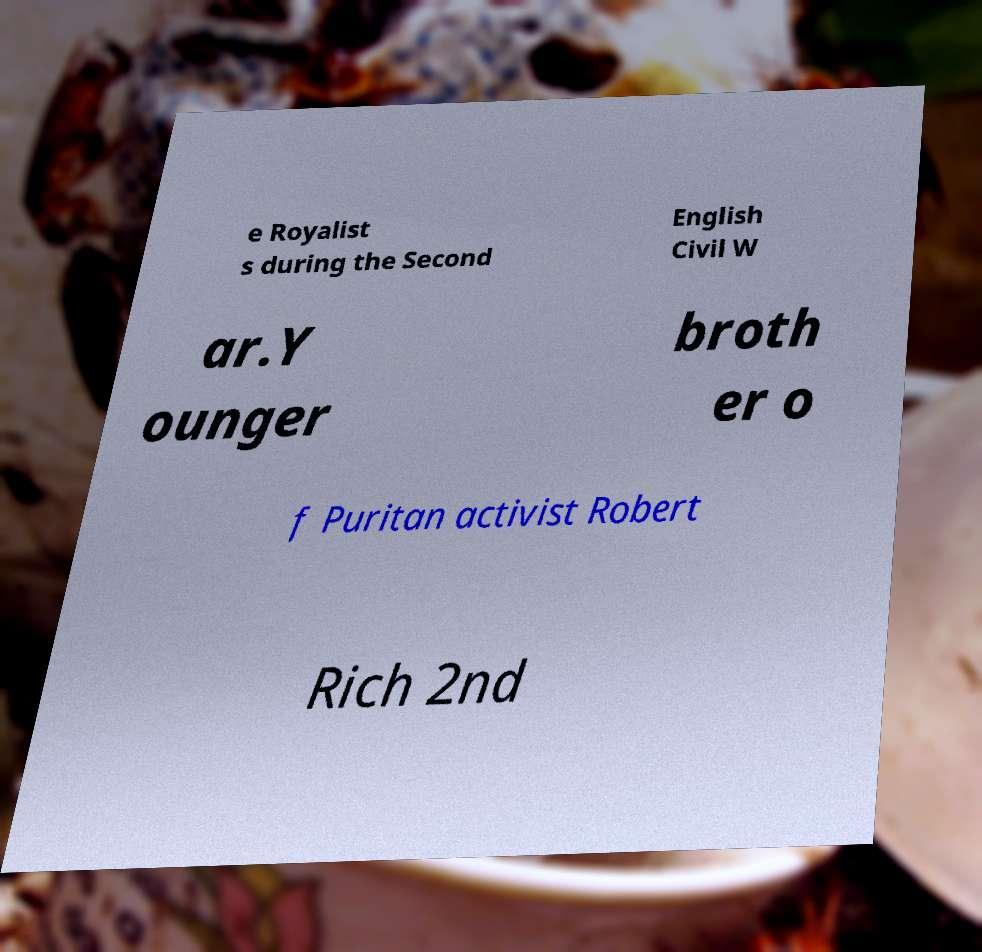Could you extract and type out the text from this image? e Royalist s during the Second English Civil W ar.Y ounger broth er o f Puritan activist Robert Rich 2nd 